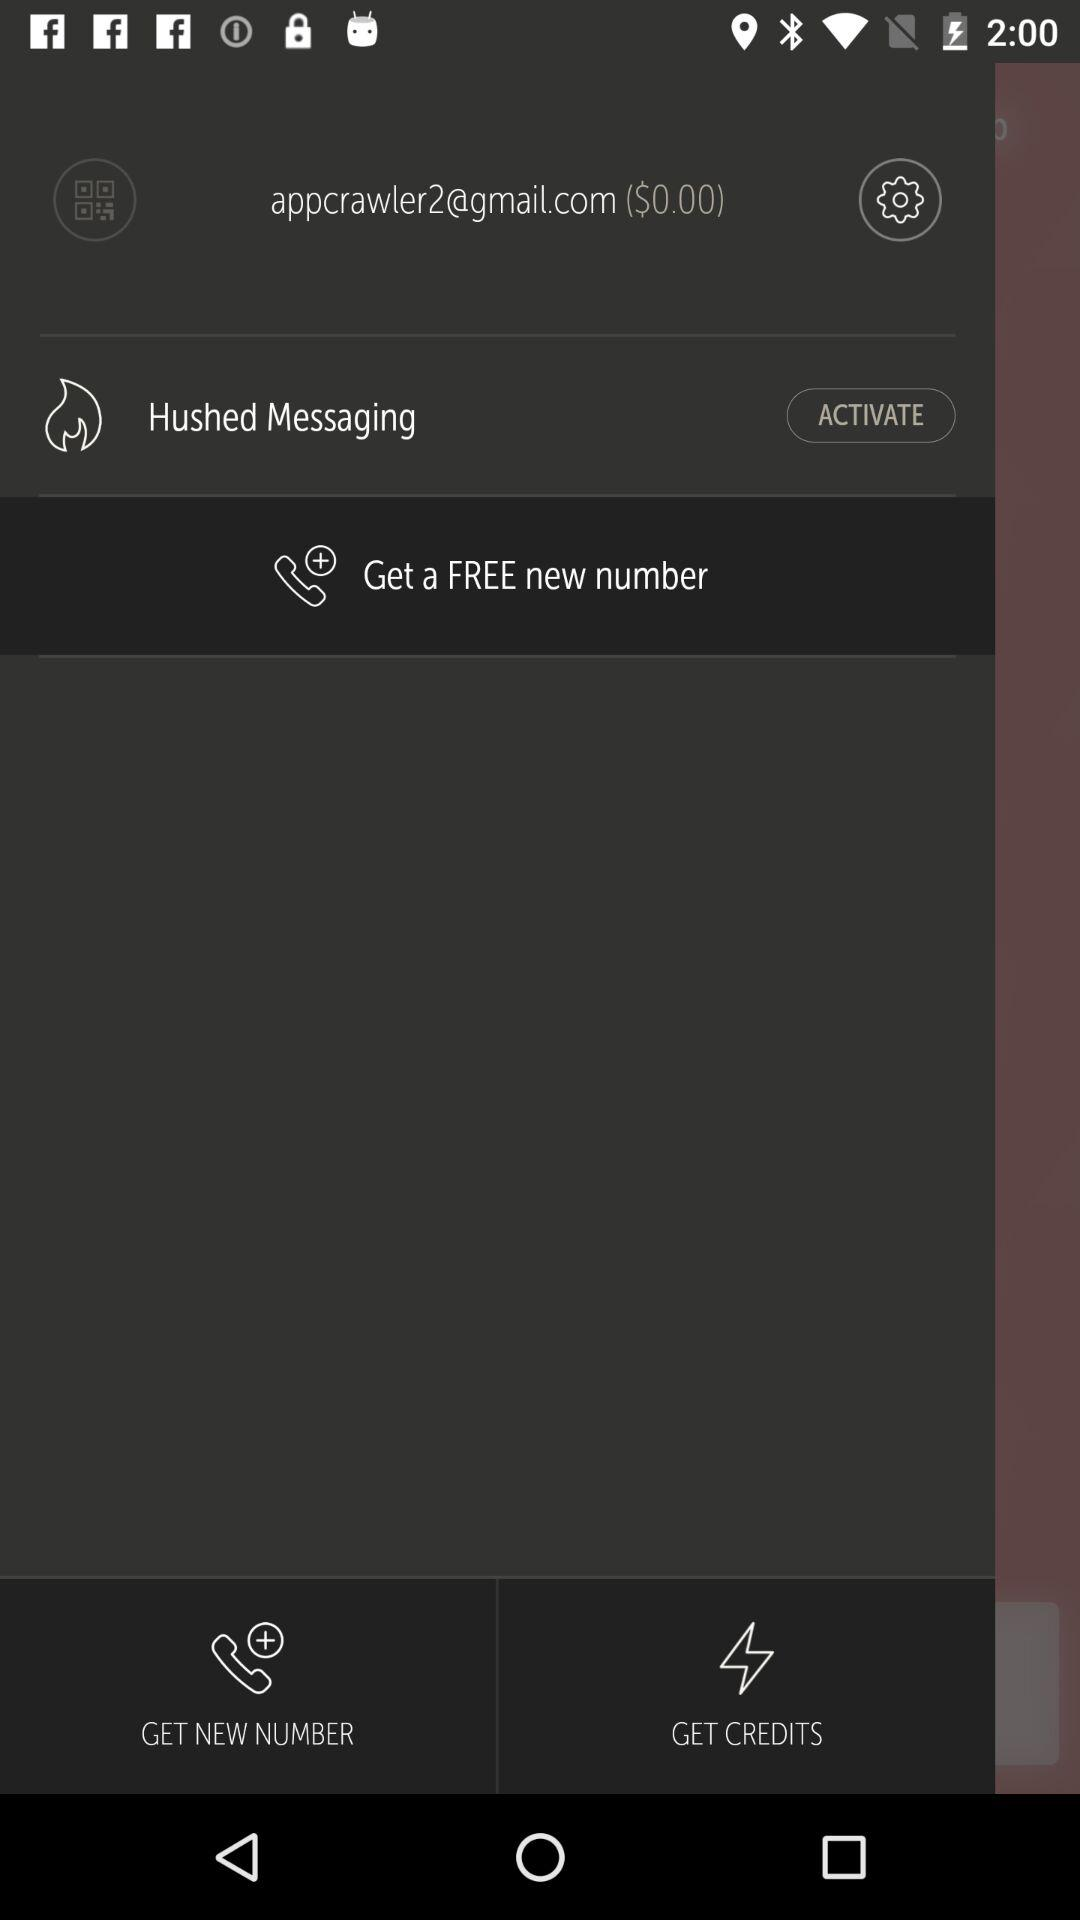What is the email address? The email address is appcrawler2@gmail.com. 